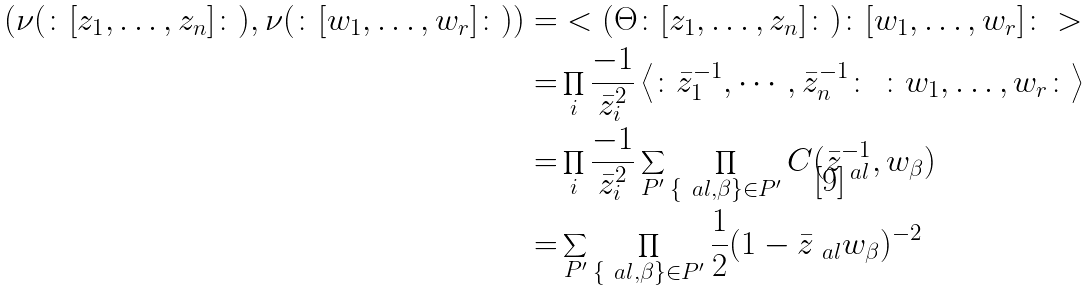Convert formula to latex. <formula><loc_0><loc_0><loc_500><loc_500>\left ( \nu ( \colon [ z _ { 1 } , \dots , z _ { n } ] \colon ) , \nu ( \colon [ w _ { 1 } , \dots , w _ { r } ] \colon ) \right ) = & < ( \Theta \colon [ z _ { 1 } , \dots , z _ { n } ] \colon ) \colon [ w _ { 1 } , \dots , w _ { r } ] \colon > \\ = & \prod _ { i } \frac { - 1 } { \bar { z } _ { i } ^ { 2 } } \left < \colon \bar { z } _ { 1 } ^ { - 1 } , \cdots , \bar { z } _ { n } ^ { - 1 } \colon \ \colon w _ { 1 } , \dots , w _ { r } \colon \right > \\ = & \prod _ { i } \frac { - 1 } { \bar { z } _ { i } ^ { 2 } } \sum _ { P ^ { \prime } } \prod _ { \{ \ a l , \beta \} \in P ^ { \prime } } C ( \bar { z } _ { \ a l } ^ { - 1 } , w _ { \beta } ) \\ = & \sum _ { P ^ { \prime } } \prod _ { \{ \ a l , \beta \} \in P ^ { \prime } } \frac { 1 } { 2 } ( 1 - \bar { z } _ { \ a l } w _ { \beta } ) ^ { - 2 } \\</formula> 